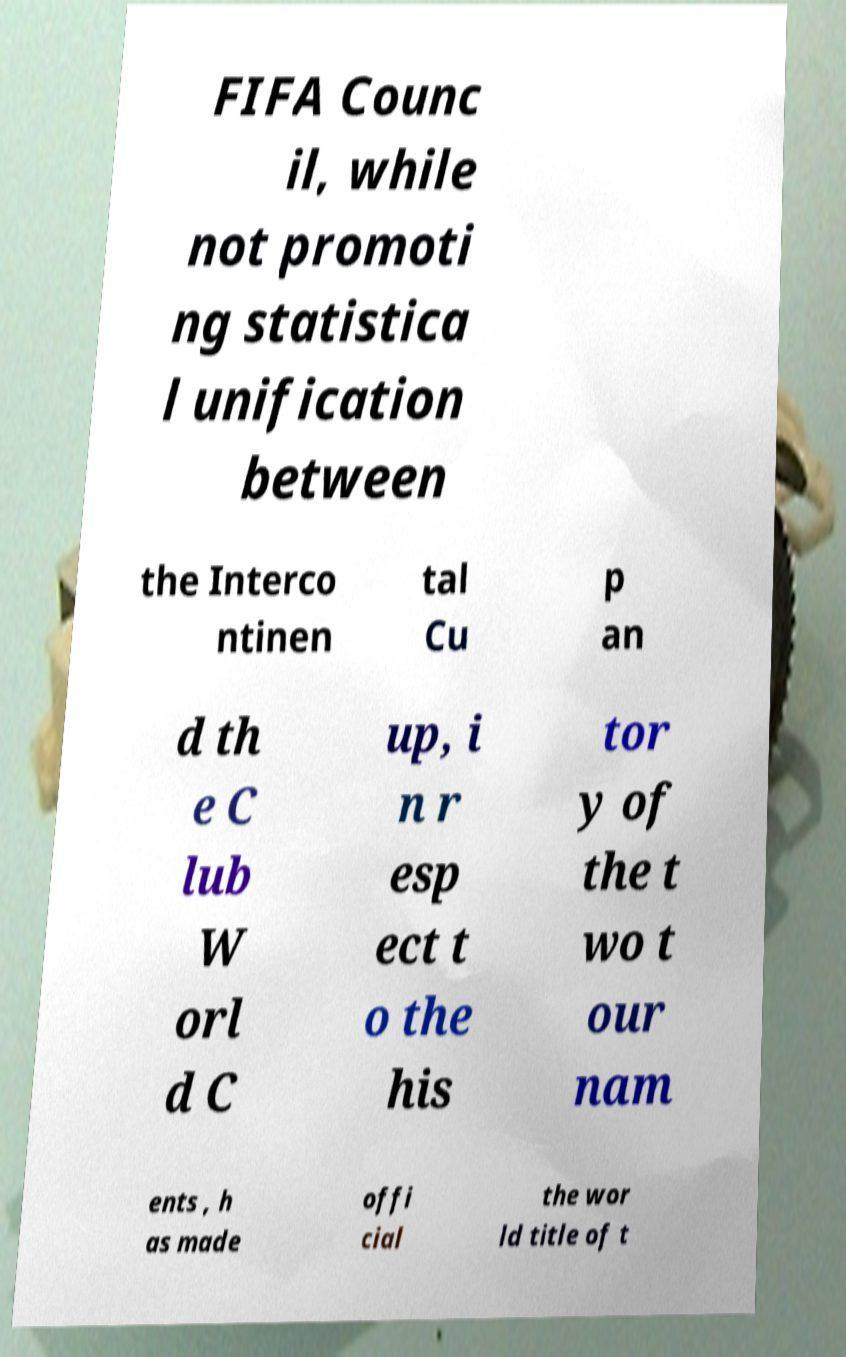Can you read and provide the text displayed in the image?This photo seems to have some interesting text. Can you extract and type it out for me? FIFA Counc il, while not promoti ng statistica l unification between the Interco ntinen tal Cu p an d th e C lub W orl d C up, i n r esp ect t o the his tor y of the t wo t our nam ents , h as made offi cial the wor ld title of t 